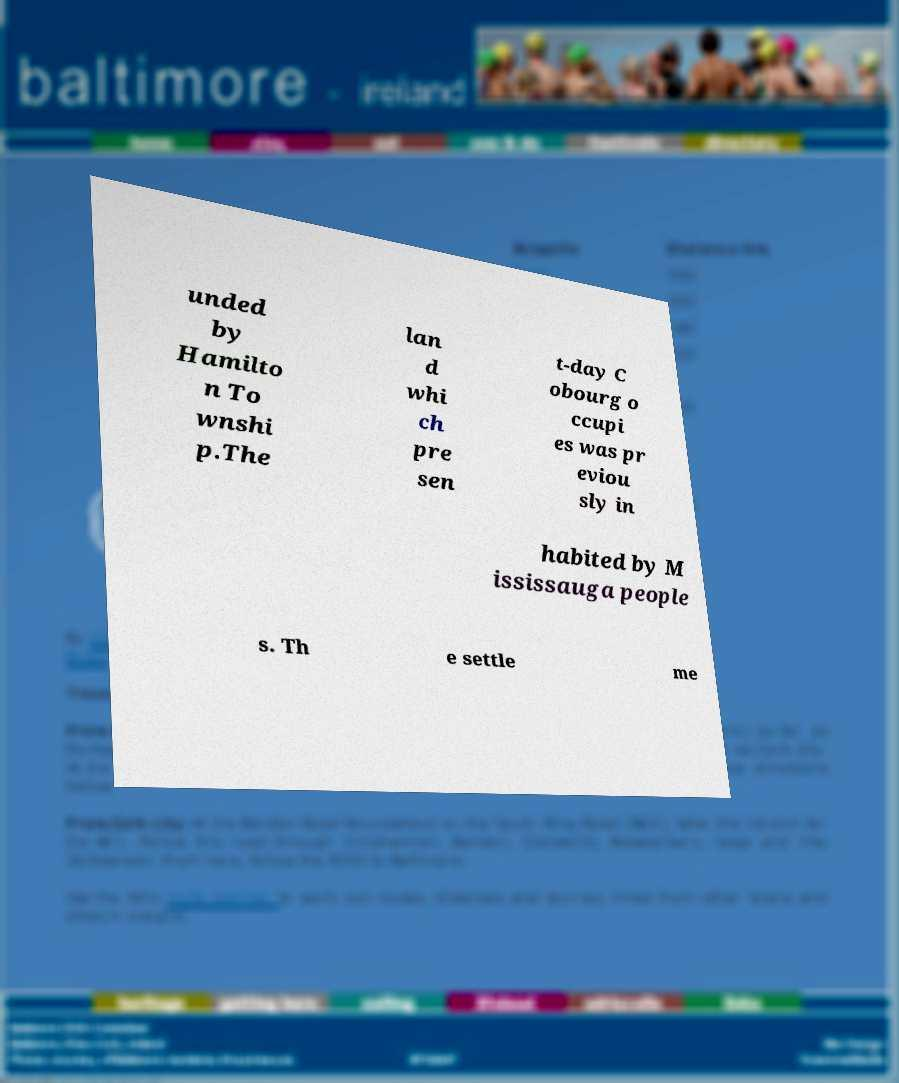For documentation purposes, I need the text within this image transcribed. Could you provide that? unded by Hamilto n To wnshi p.The lan d whi ch pre sen t-day C obourg o ccupi es was pr eviou sly in habited by M ississauga people s. Th e settle me 